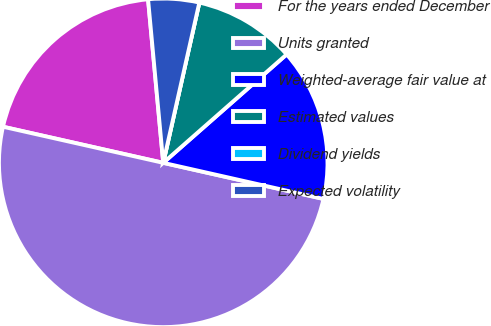Convert chart to OTSL. <chart><loc_0><loc_0><loc_500><loc_500><pie_chart><fcel>For the years ended December<fcel>Units granted<fcel>Weighted-average fair value at<fcel>Estimated values<fcel>Dividend yields<fcel>Expected volatility<nl><fcel>20.0%<fcel>50.0%<fcel>15.0%<fcel>10.0%<fcel>0.0%<fcel>5.0%<nl></chart> 